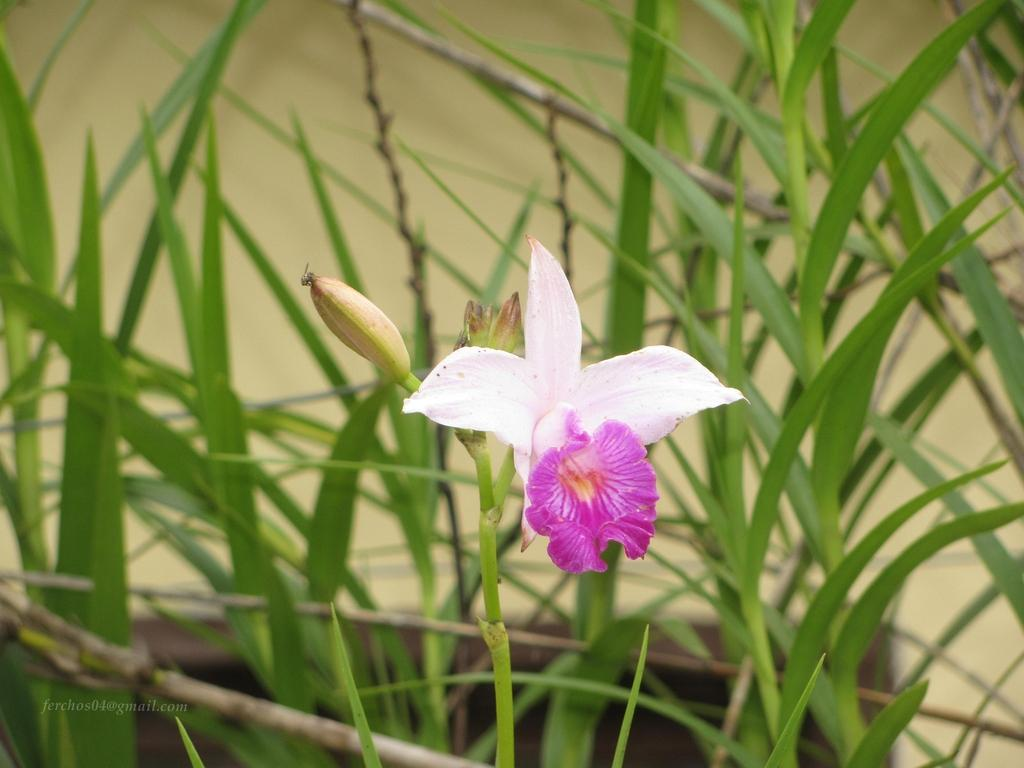What type of plant can be seen in the picture? There is a flower in the picture. Are there any unopened parts of the flower visible? Yes, there are buds in the picture. What other parts of the plant can be seen in the picture? There are leaves in the picture. How would you describe the background of the image? The background of the image is blurred. Is there any additional information or branding on the image? Yes, there is a watermark on the image. How many pizzas are being held by the owl in the image? There is no owl or pizza present in the image. What type of wool is being used to make the sweater in the image? There is no sweater or wool present in the image. 